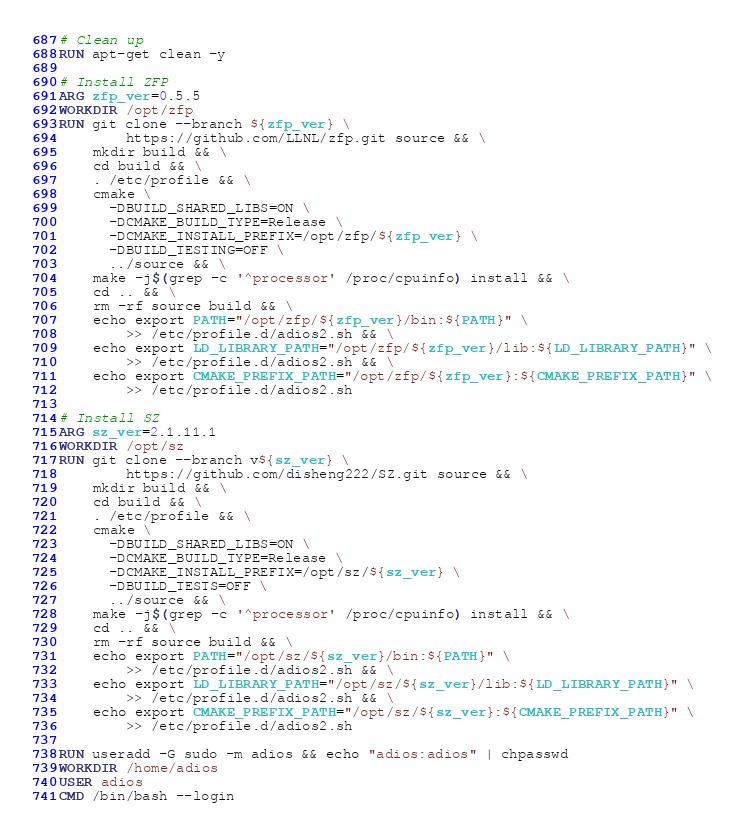Convert code to text. <code><loc_0><loc_0><loc_500><loc_500><_Dockerfile_>
# Clean up
RUN apt-get clean -y

# Install ZFP
ARG zfp_ver=0.5.5
WORKDIR /opt/zfp
RUN git clone --branch ${zfp_ver} \
        https://github.com/LLNL/zfp.git source && \
    mkdir build && \
    cd build && \
    . /etc/profile && \
    cmake \
      -DBUILD_SHARED_LIBS=ON \
      -DCMAKE_BUILD_TYPE=Release \
      -DCMAKE_INSTALL_PREFIX=/opt/zfp/${zfp_ver} \
      -DBUILD_TESTING=OFF \
      ../source && \
    make -j$(grep -c '^processor' /proc/cpuinfo) install && \
    cd .. && \
    rm -rf source build && \
    echo export PATH="/opt/zfp/${zfp_ver}/bin:${PATH}" \
        >> /etc/profile.d/adios2.sh && \
    echo export LD_LIBRARY_PATH="/opt/zfp/${zfp_ver}/lib:${LD_LIBRARY_PATH}" \
        >> /etc/profile.d/adios2.sh && \
    echo export CMAKE_PREFIX_PATH="/opt/zfp/${zfp_ver}:${CMAKE_PREFIX_PATH}" \
        >> /etc/profile.d/adios2.sh

# Install SZ
ARG sz_ver=2.1.11.1
WORKDIR /opt/sz
RUN git clone --branch v${sz_ver} \
        https://github.com/disheng222/SZ.git source && \
    mkdir build && \
    cd build && \
    . /etc/profile && \
    cmake \
      -DBUILD_SHARED_LIBS=ON \
      -DCMAKE_BUILD_TYPE=Release \
      -DCMAKE_INSTALL_PREFIX=/opt/sz/${sz_ver} \
      -DBUILD_TESTS=OFF \
      ../source && \
    make -j$(grep -c '^processor' /proc/cpuinfo) install && \
    cd .. && \
    rm -rf source build && \
    echo export PATH="/opt/sz/${sz_ver}/bin:${PATH}" \
        >> /etc/profile.d/adios2.sh && \
    echo export LD_LIBRARY_PATH="/opt/sz/${sz_ver}/lib:${LD_LIBRARY_PATH}" \
        >> /etc/profile.d/adios2.sh && \
    echo export CMAKE_PREFIX_PATH="/opt/sz/${sz_ver}:${CMAKE_PREFIX_PATH}" \
        >> /etc/profile.d/adios2.sh

RUN useradd -G sudo -m adios && echo "adios:adios" | chpasswd
WORKDIR /home/adios
USER adios
CMD /bin/bash --login
</code> 